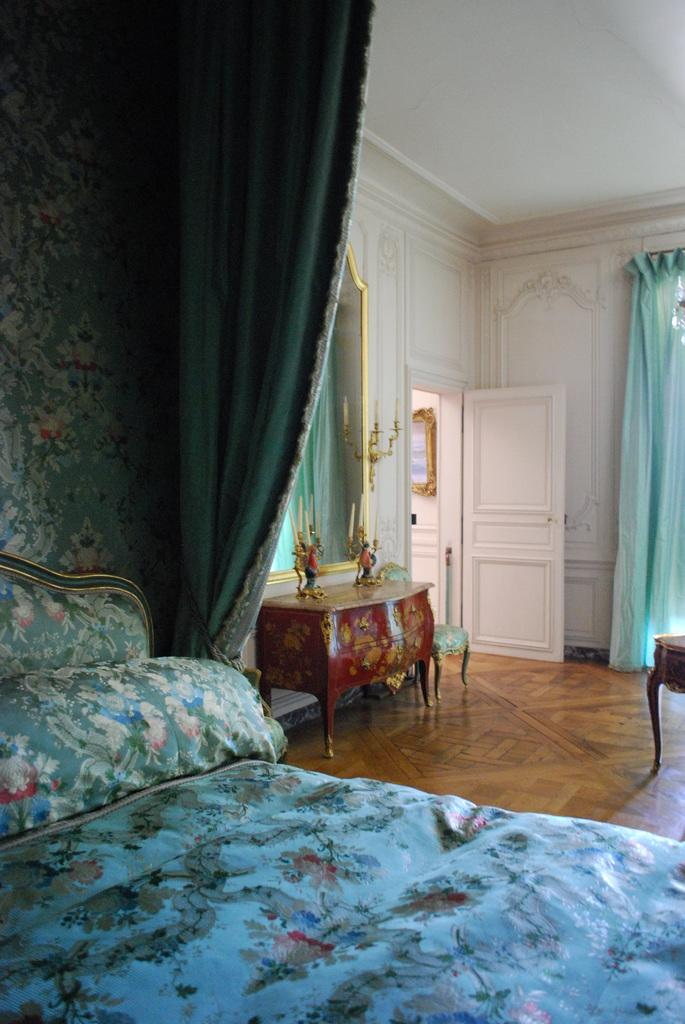What is the main object in the center of the image? There is a bed in the center of the image. What can be seen in the background of the image? There is a door in the background of the image. What is located at the top of the image? There is a ceiling at the top of the image. What other furniture is present in the image? There is a table in the image. What type of window treatment is visible in the image? There are curtains in the image. Who is the owner of the iron in the image? There is no iron present in the image. 